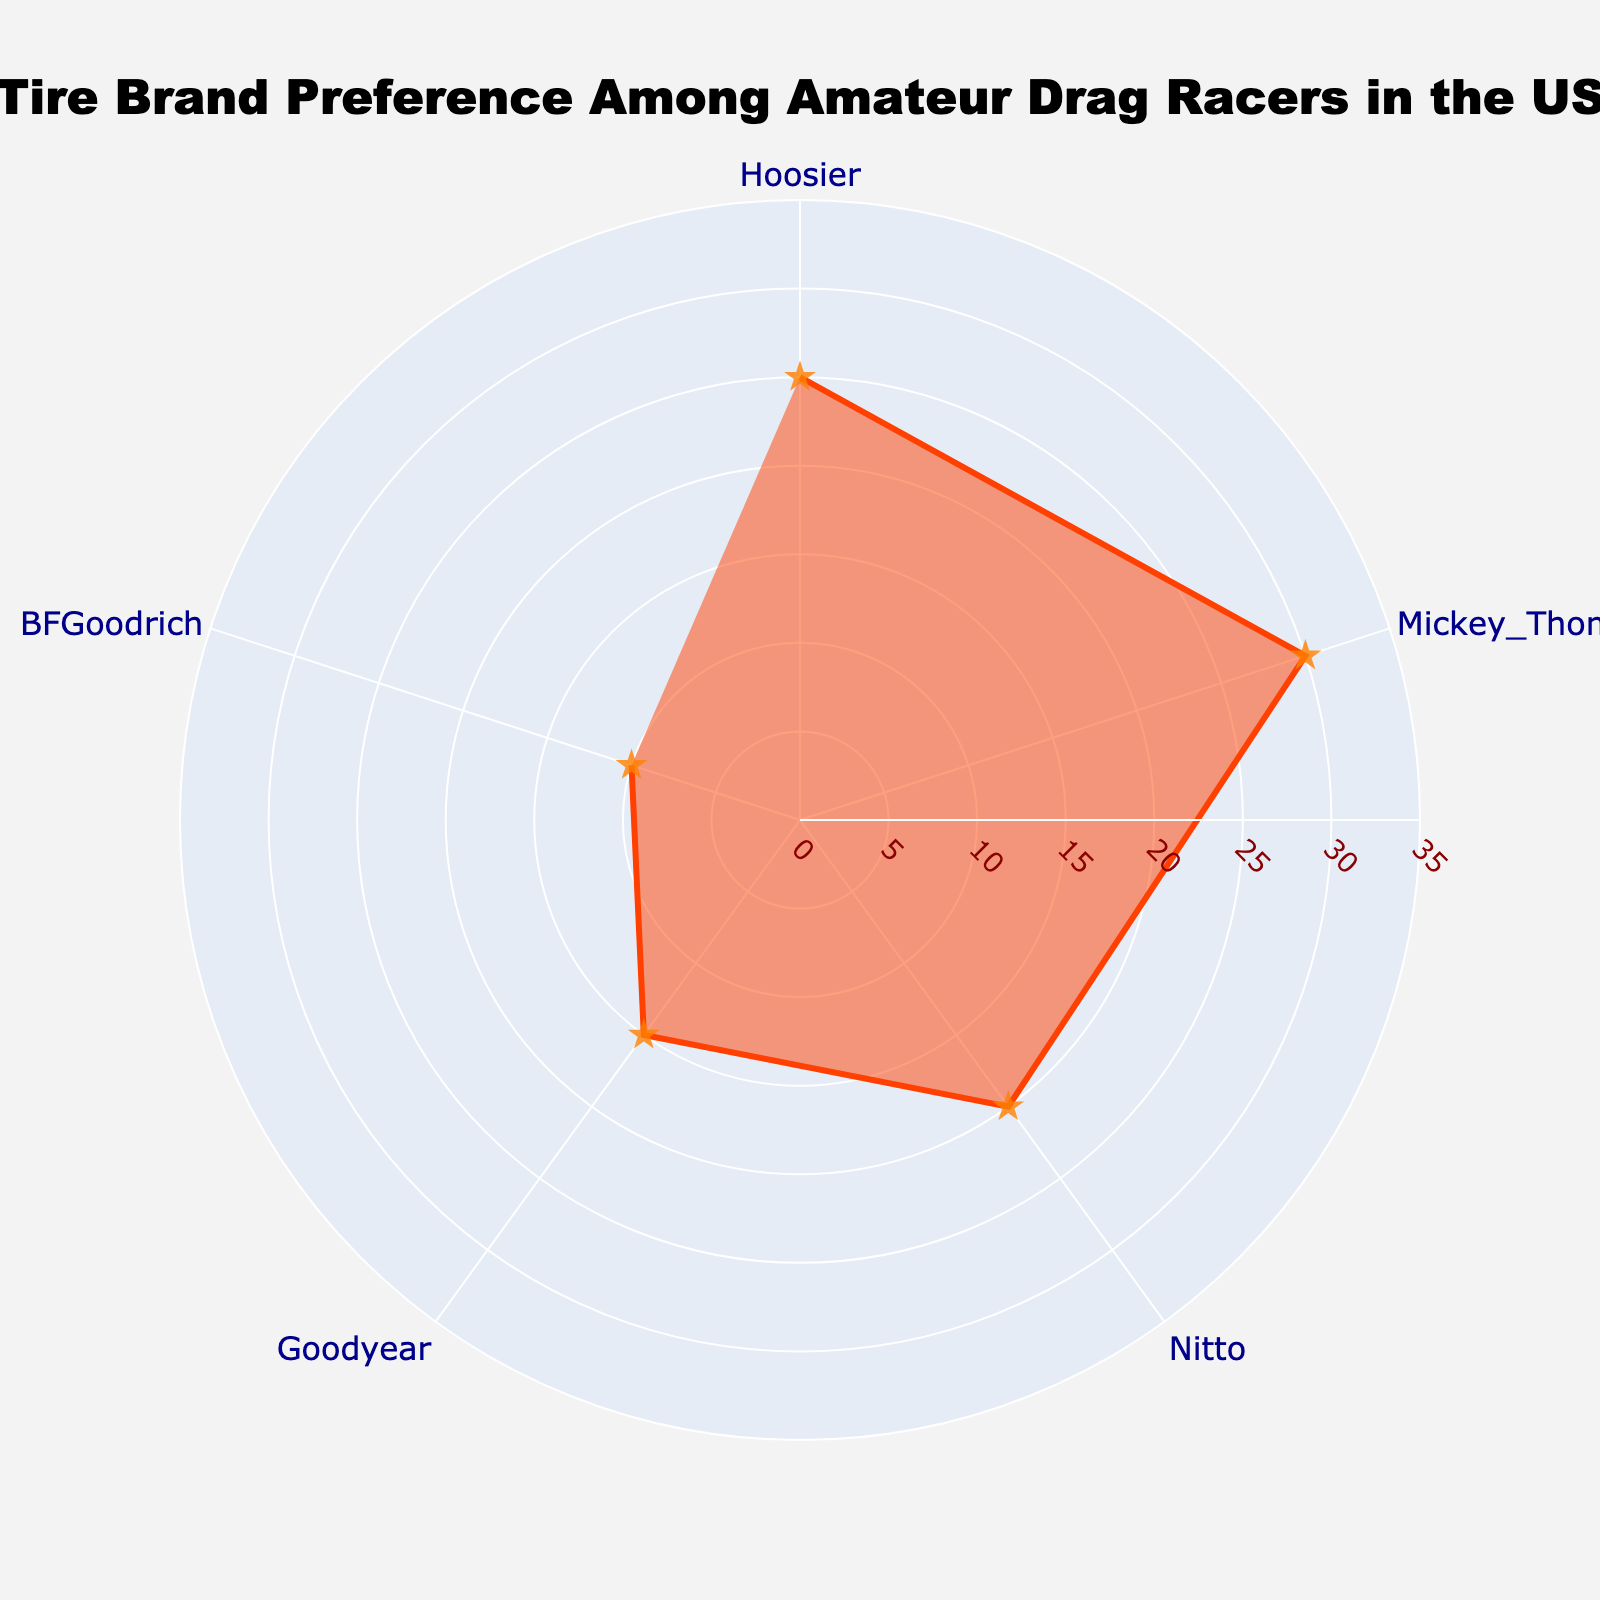What is the title of the chart? The title of the figure is located at the top and it provides an overall description. It states, "Tire Brand Preference Among Amateur Drag Racers in the US."
Answer: Tire Brand Preference Among Amateur Drag Racers in the US Which tire brand has the highest user percentage? By examining the values on the polar chart, it's clear that the brand at the highest point on the radial axis has the highest user percentage.
Answer: Mickey Thompson What is the user percentage for BFGoodrich? Looking at the section of the polar chart labeled for BFGoodrich, the corresponding radial distance (percentage) is found.
Answer: 10 How many tire brands are included in the chart? By counting the distinct labels along the angular axis of the polar chart, we can determine the number of tire brands represented.
Answer: 5 Which tire brand has a user percentage of 20%? By tracing the radial distance to the value of 20% and checking the corresponding brand label, we find the answer.
Answer: Nitto What is the combined user percentage of Nitto and Goodyear? Adding the user percentage values for the brands Nitto (20%) and Goodyear (15%) from the chart gives the sum.
Answer: 35 Which tire brand has the second lowest user percentage? Sorting the user percentages in ascending order and identifying the second one from the bottom will give us the answer.
Answer: Goodyear How much higher in percentage is Mickey Thompson's user percentage compared to Hoosier's? The difference is calculated by subtracting the user percentage of Hoosier (25%) from Mickey Thompson (30%).
Answer: 5 What is the average user percentage across all the tire brands shown? To find the average, sum all the user percentages (25 + 30 + 20 + 15 + 10) and then divide by the number of brands (5).
Answer: 20 If Goodyear's user percentage increased by 5%, what would be the new percentage? Adding the increase to Goodyear's current value (15 + 5) gives the new percentage.
Answer: 20 